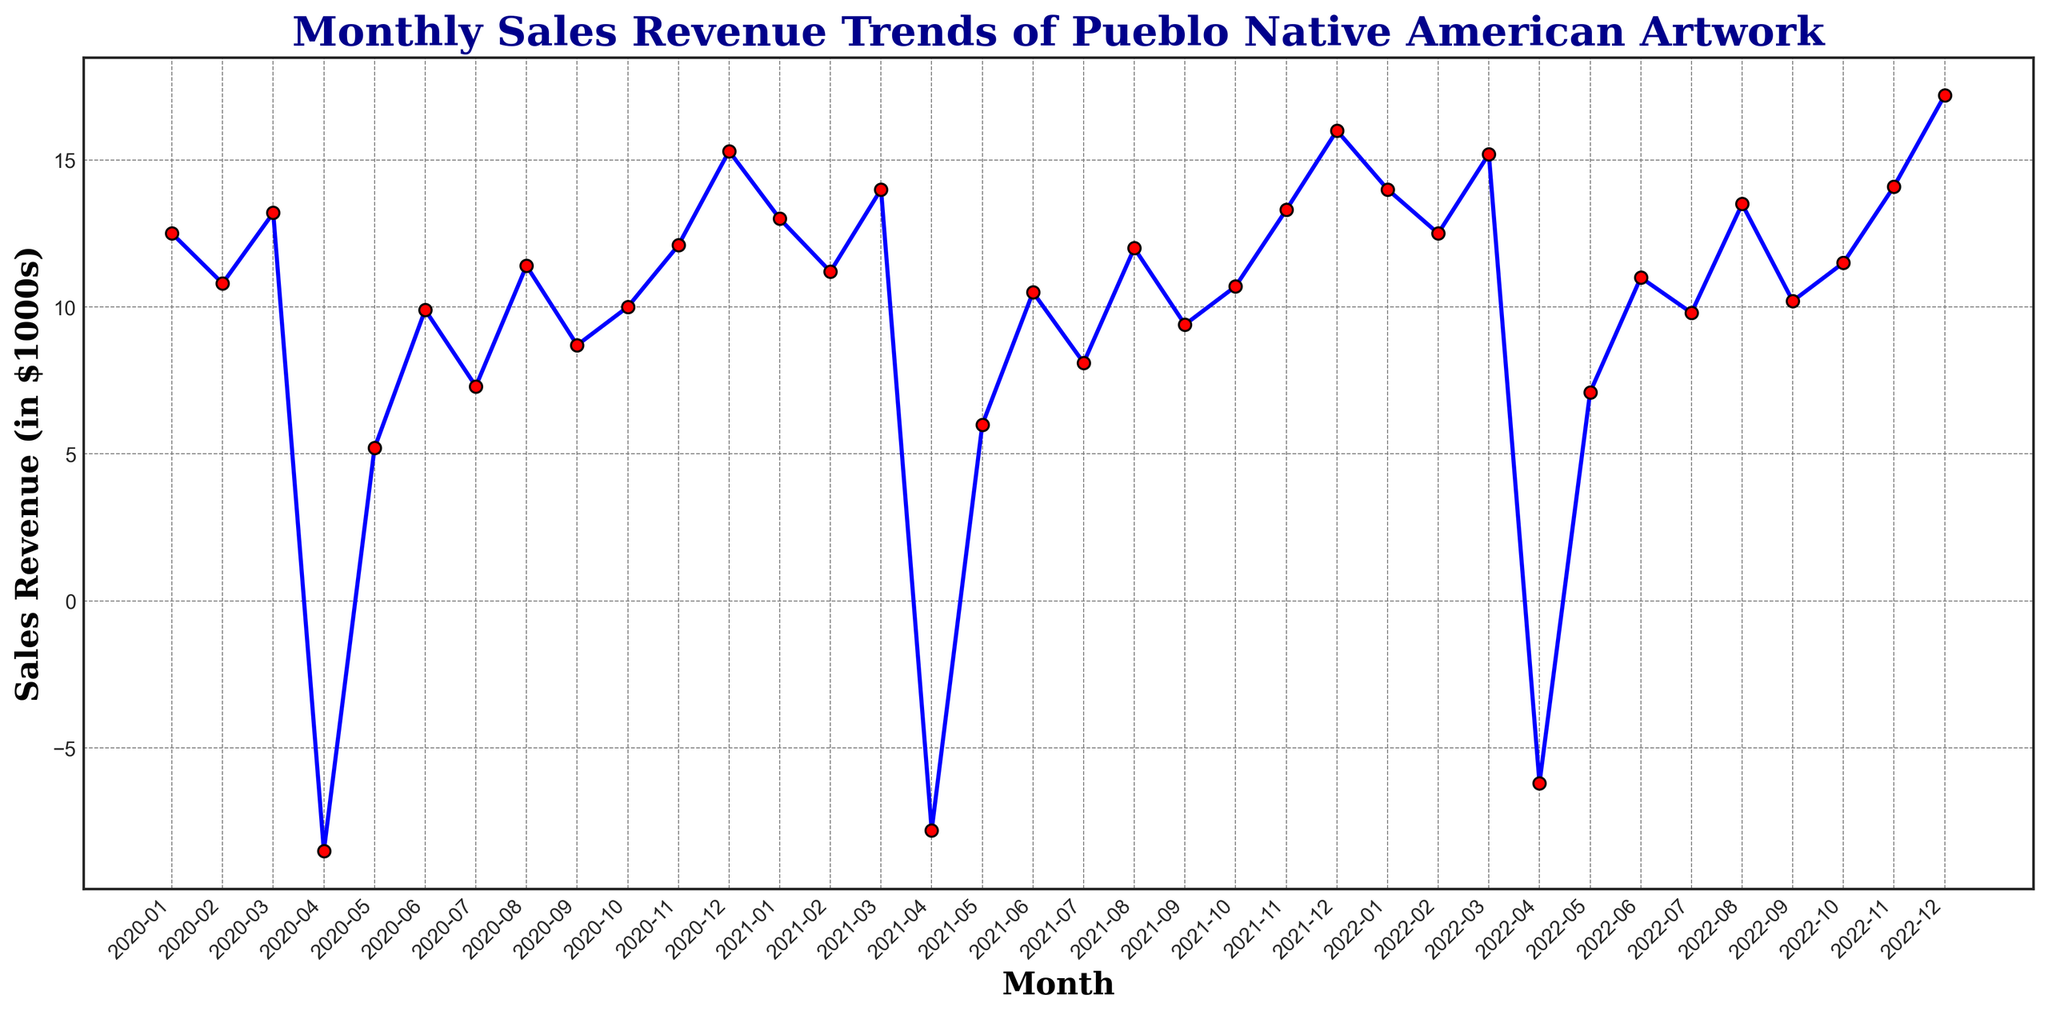What month had the highest sales revenue? The month with the highest sales revenue can be observed where the line reaches the peak. This occurs in December 2022 with a sales revenue of $17.2k.
Answer: December 2022 Which months experienced negative sales revenue, and what were the values? To find the months with negative sales revenue, look for dips below the zero line on the y-axis. These months are April 2020 (-$8.5k), April 2021 (-$7.8k), and April 2022 (-$6.2k).
Answer: April 2020, April 2021, April 2022 Between which two consecutive months was the largest increase in sales revenue observed? To identify the largest increase, observe the steepest upward slope between two consecutive points along the x-axis. The largest increase is between November and December 2022, from $14.1k to $17.2k.
Answer: November 2022 to December 2022 What is the average sales revenue in the month of December over the three years? Extract the sales revenue values for December 2020 ($15.3k), December 2021 ($16.0k), and December 2022 ($17.2k). The average is calculated as (15.3 + 16.0 + 17.2) / 3 which equals approximately $16.17k.
Answer: $16.17k Compare the sales revenue of May over the three years. Did it increase or decrease? The sales revenue for May 2020 is $5.2k, for May 2021 is $6.0k, and for May 2022 is $7.1k. Comparing these values, it continuously increased.
Answer: Increased In which month and year did sales revenue regain positive values following a period of negative values? Following the negative sales revenue in April 2020 (-$8.5k), May 2020 regained positive values with $5.2k. Similarly, after April 2021 (-$7.8k), May 2021 saw $6.0k; and after April 2022 (-$6.2k), May 2022 had $7.1k.
Answer: May 2020, May 2021, May 2022 How does the October 2021 sales revenue compare to October 2022? October 2021 has $10.7k and October 2022 has $11.5k. 2022 has higher sales revenue.
Answer: October 2022 is higher What was the overall trend in sales revenue from January to December of each year? For each year, trace the line from January to December and note the trend. Observations show that sales generally start lower in the year and peak towards December.
Answer: Increasing trend Are there any consistent seasonal patterns visible in the sales revenue trends? Consistently, April records a significant drop, and December shows a peak in sales revenues every year.
Answer: April drops, December peaks 